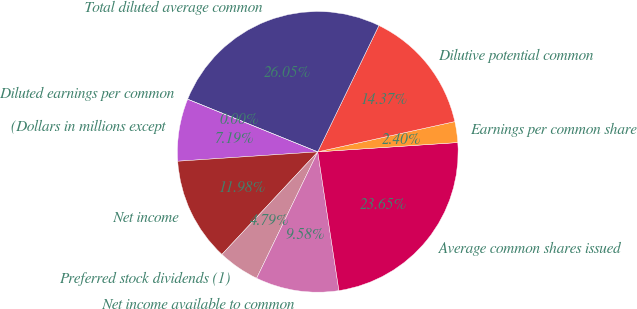<chart> <loc_0><loc_0><loc_500><loc_500><pie_chart><fcel>(Dollars in millions except<fcel>Net income<fcel>Preferred stock dividends (1)<fcel>Net income available to common<fcel>Average common shares issued<fcel>Earnings per common share<fcel>Dilutive potential common<fcel>Total diluted average common<fcel>Diluted earnings per common<nl><fcel>7.19%<fcel>11.98%<fcel>4.79%<fcel>9.58%<fcel>23.65%<fcel>2.4%<fcel>14.37%<fcel>26.05%<fcel>0.0%<nl></chart> 